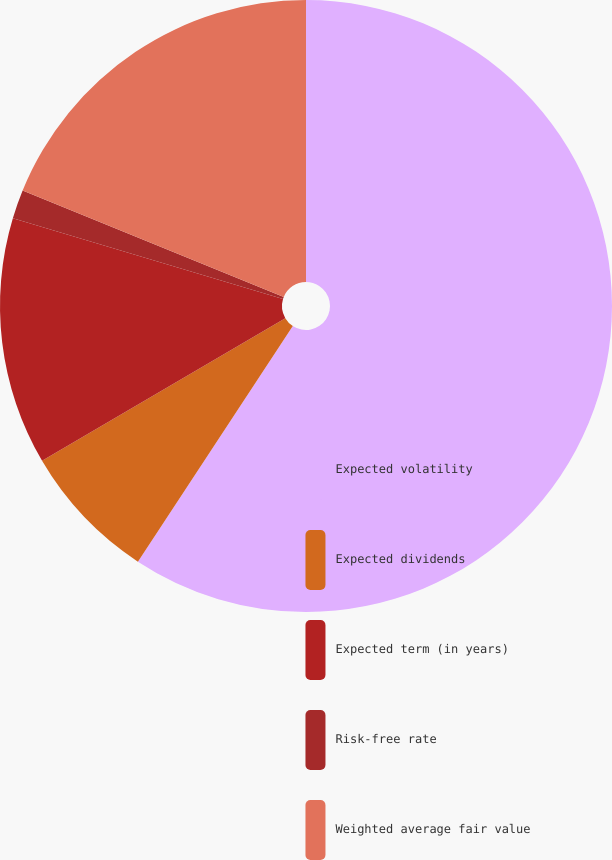<chart> <loc_0><loc_0><loc_500><loc_500><pie_chart><fcel>Expected volatility<fcel>Expected dividends<fcel>Expected term (in years)<fcel>Risk-free rate<fcel>Weighted average fair value<nl><fcel>59.25%<fcel>7.3%<fcel>13.07%<fcel>1.53%<fcel>18.84%<nl></chart> 